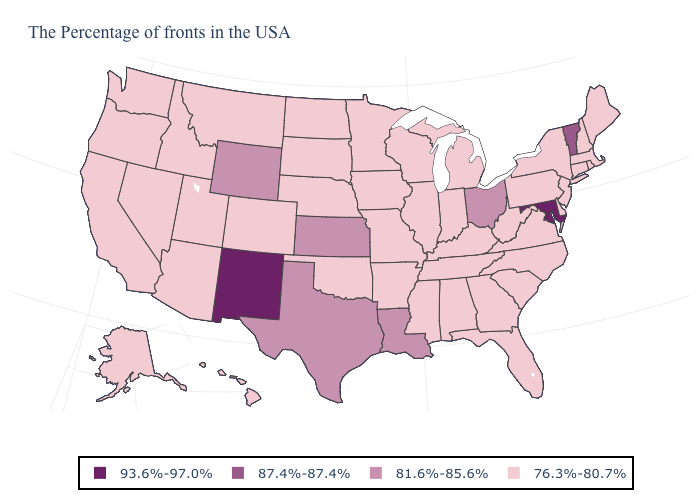What is the highest value in states that border Colorado?
Give a very brief answer. 93.6%-97.0%. Which states hav the highest value in the West?
Answer briefly. New Mexico. What is the value of Vermont?
Quick response, please. 87.4%-87.4%. Which states have the lowest value in the South?
Concise answer only. Delaware, Virginia, North Carolina, South Carolina, West Virginia, Florida, Georgia, Kentucky, Alabama, Tennessee, Mississippi, Arkansas, Oklahoma. Does Arizona have a higher value than Indiana?
Concise answer only. No. What is the lowest value in the MidWest?
Give a very brief answer. 76.3%-80.7%. Which states have the highest value in the USA?
Concise answer only. Maryland, New Mexico. What is the value of Ohio?
Be succinct. 81.6%-85.6%. Does Arkansas have a higher value than Wyoming?
Quick response, please. No. What is the lowest value in the West?
Give a very brief answer. 76.3%-80.7%. Name the states that have a value in the range 76.3%-80.7%?
Write a very short answer. Maine, Massachusetts, Rhode Island, New Hampshire, Connecticut, New York, New Jersey, Delaware, Pennsylvania, Virginia, North Carolina, South Carolina, West Virginia, Florida, Georgia, Michigan, Kentucky, Indiana, Alabama, Tennessee, Wisconsin, Illinois, Mississippi, Missouri, Arkansas, Minnesota, Iowa, Nebraska, Oklahoma, South Dakota, North Dakota, Colorado, Utah, Montana, Arizona, Idaho, Nevada, California, Washington, Oregon, Alaska, Hawaii. Does Mississippi have a lower value than Iowa?
Answer briefly. No. What is the value of Texas?
Give a very brief answer. 81.6%-85.6%. 